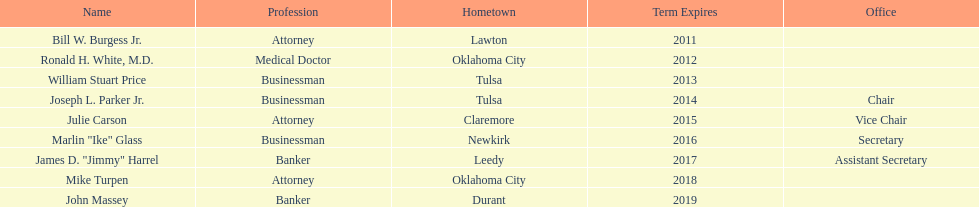How many individuals have identified themselves as businessmen in the list of members? 3. 